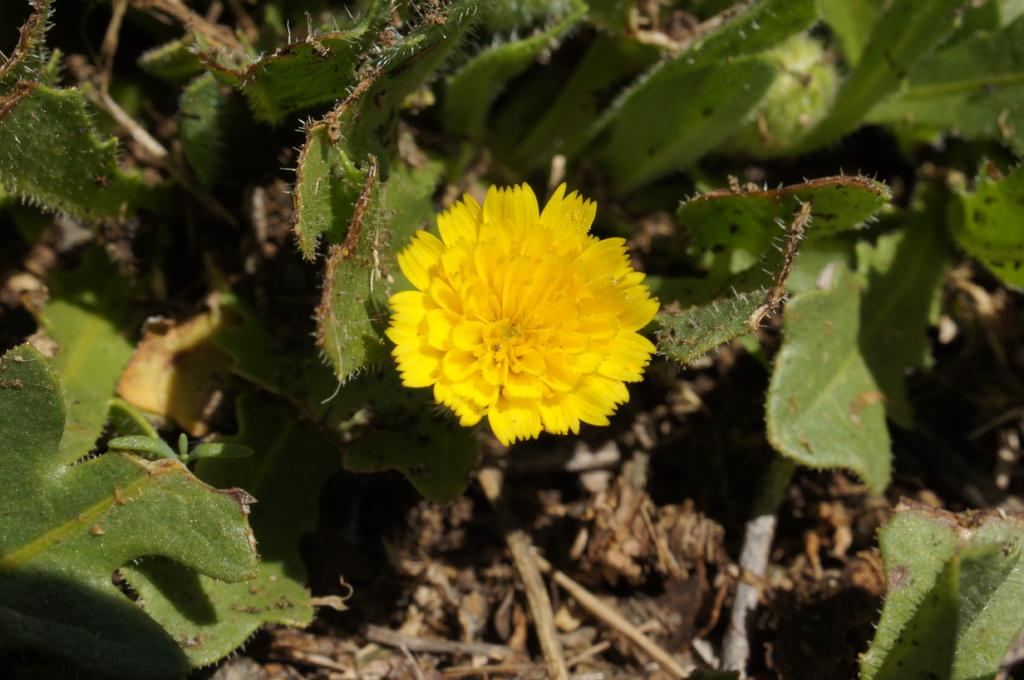What is the main subject of the image? There is a plant with a flower in the image. Can you describe the plant's surroundings? There are plants on the land in the background of the image. What type of pot is the plant sitting in? There is no pot mentioned in the facts, and the image does not show a pot. The plant is not sitting in a pot. 